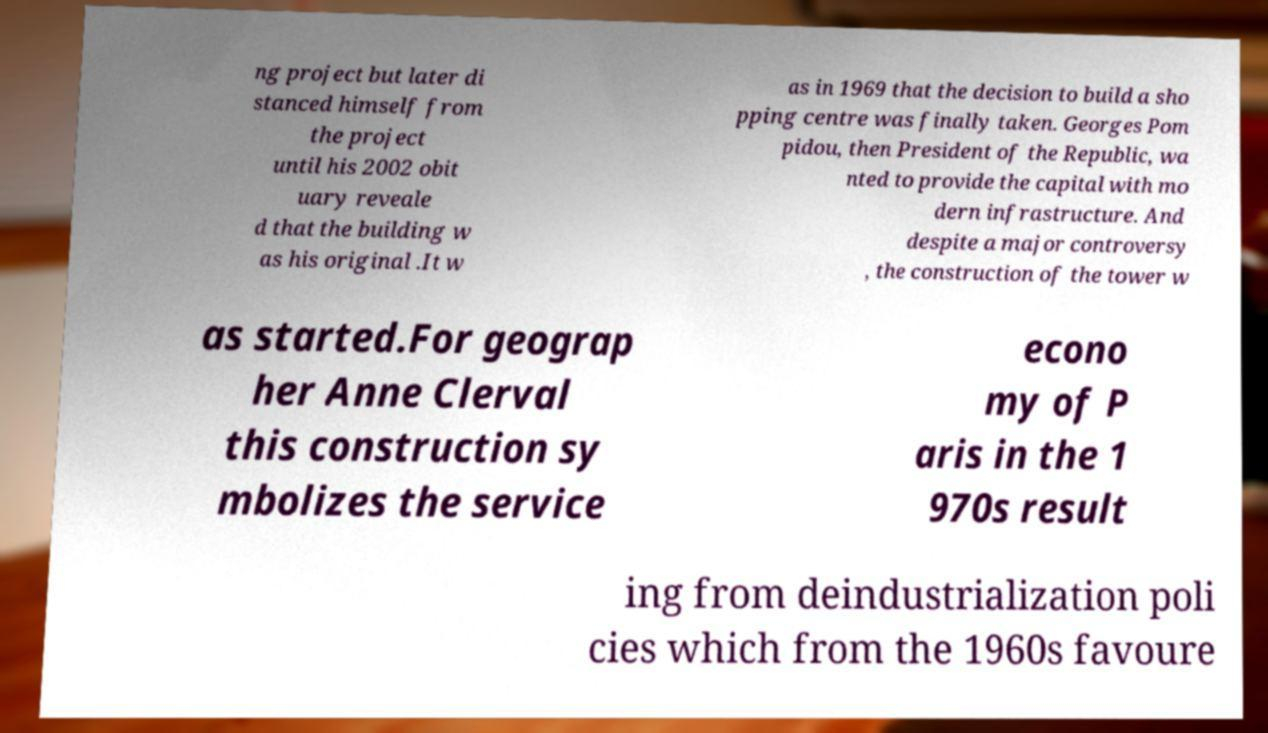Could you extract and type out the text from this image? ng project but later di stanced himself from the project until his 2002 obit uary reveale d that the building w as his original .It w as in 1969 that the decision to build a sho pping centre was finally taken. Georges Pom pidou, then President of the Republic, wa nted to provide the capital with mo dern infrastructure. And despite a major controversy , the construction of the tower w as started.For geograp her Anne Clerval this construction sy mbolizes the service econo my of P aris in the 1 970s result ing from deindustrialization poli cies which from the 1960s favoure 